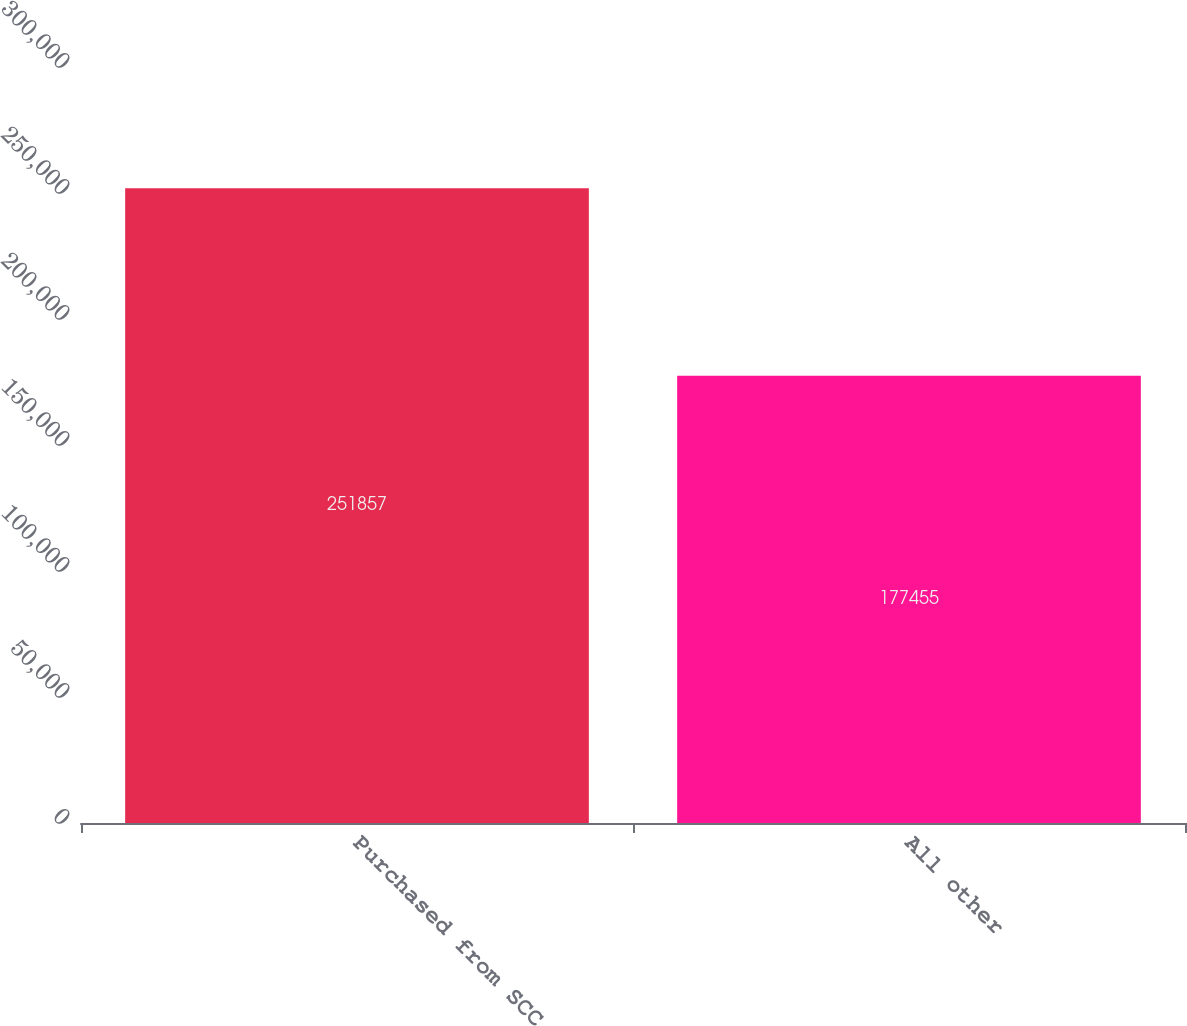Convert chart to OTSL. <chart><loc_0><loc_0><loc_500><loc_500><bar_chart><fcel>Purchased from SCC<fcel>All other<nl><fcel>251857<fcel>177455<nl></chart> 